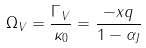Convert formula to latex. <formula><loc_0><loc_0><loc_500><loc_500>\Omega _ { V } = \frac { \Gamma _ { V } } { \kappa _ { 0 } } = \frac { - x q } { 1 - \alpha _ { J } }</formula> 